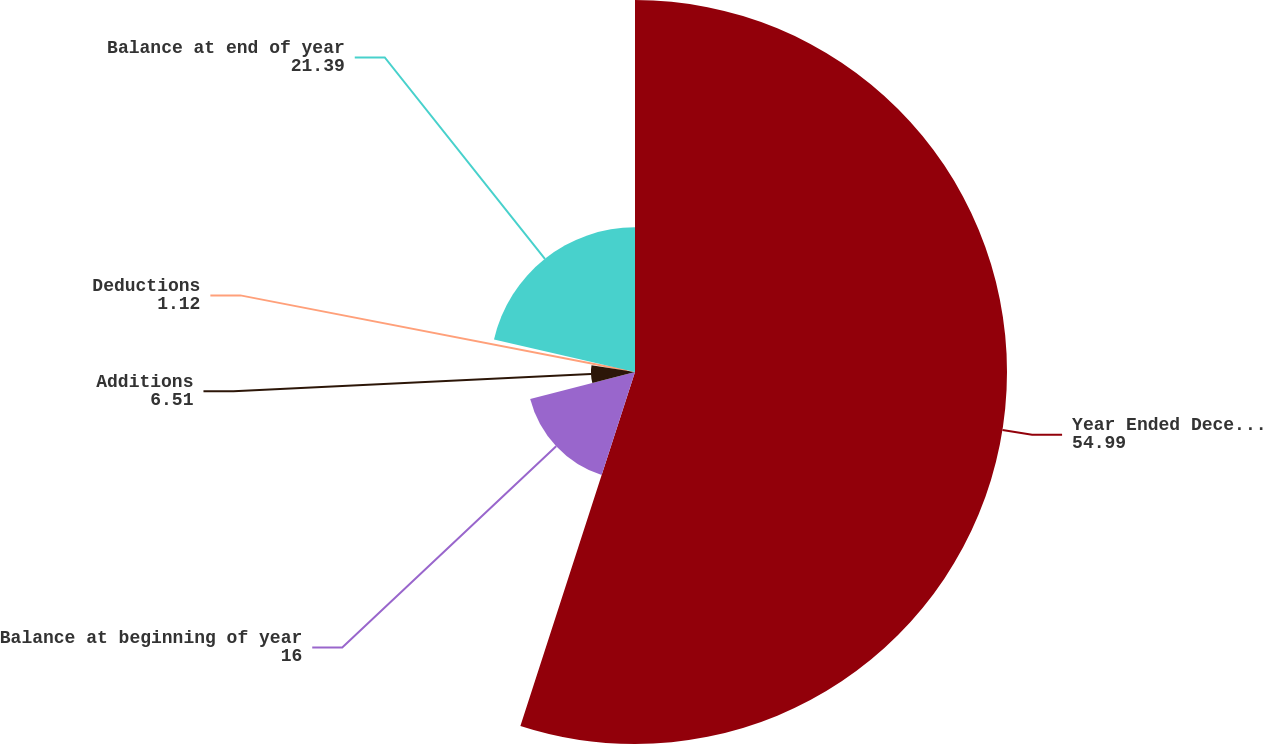Convert chart. <chart><loc_0><loc_0><loc_500><loc_500><pie_chart><fcel>Year Ended December 31<fcel>Balance at beginning of year<fcel>Additions<fcel>Deductions<fcel>Balance at end of year<nl><fcel>54.99%<fcel>16.0%<fcel>6.51%<fcel>1.12%<fcel>21.39%<nl></chart> 